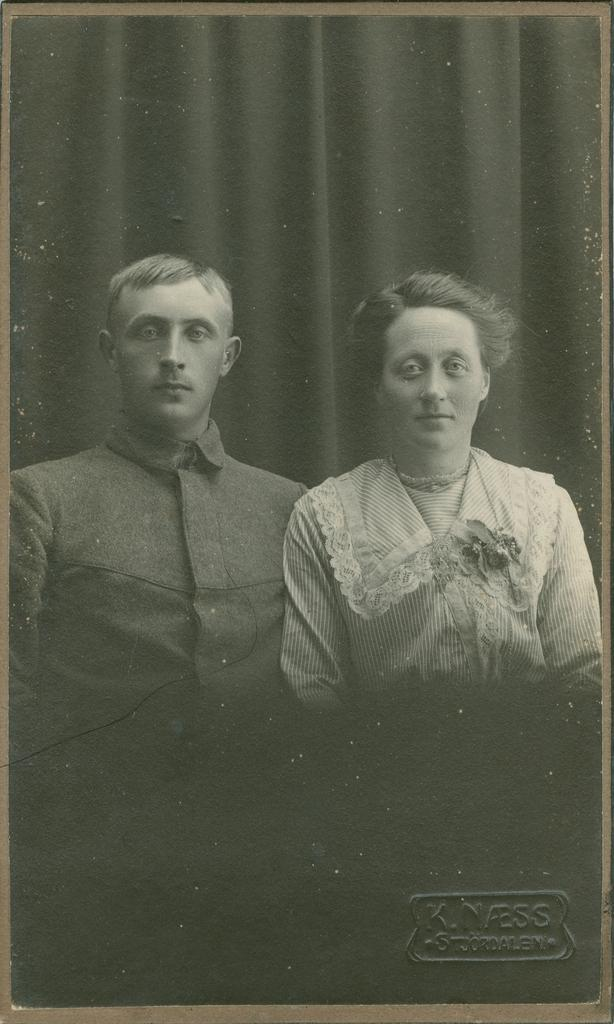What is the main subject of the image? There is a photo in the image. Who or what is depicted in the photo? The photo contains a lady and a man. What can be seen in the background of the photo? There is a curtain in the background of the photo. What type of furniture is visible in the photo? There is no furniture visible in the photo; it only contains a lady and a man with a curtain in the background. 